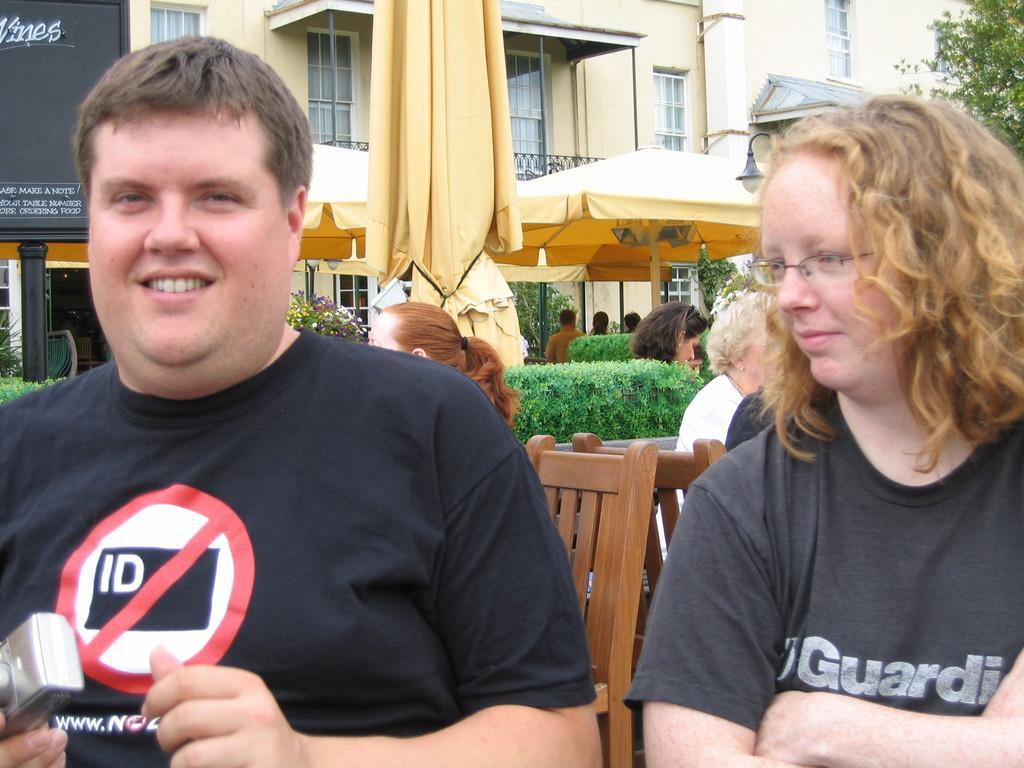<image>
Give a short and clear explanation of the subsequent image. Two people wearing black t shirts and one has ID on it. 